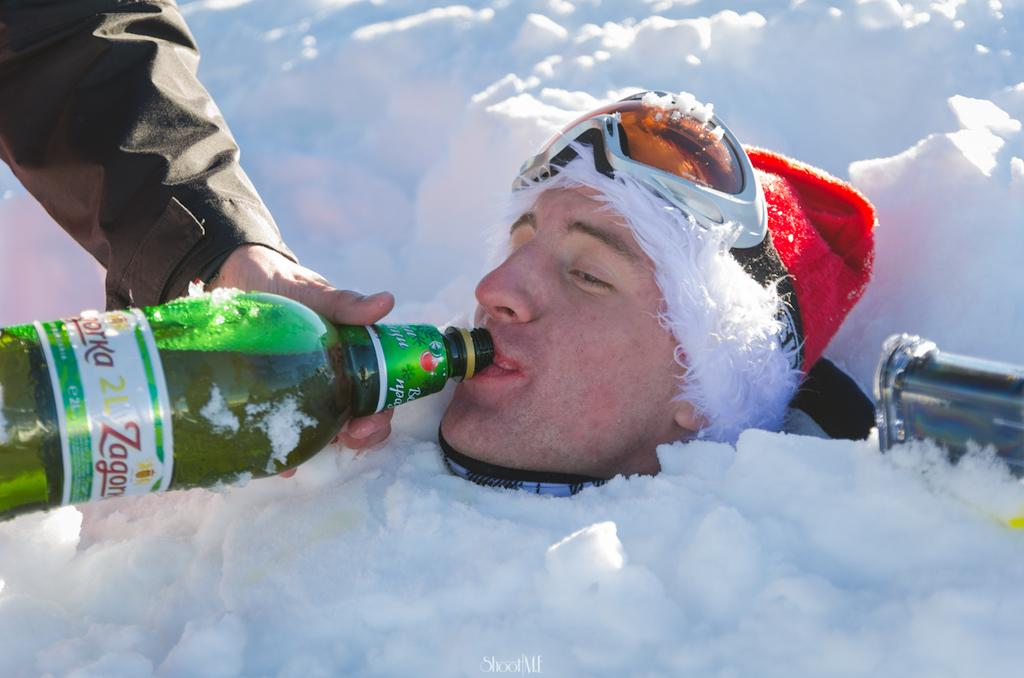What is the main subject of the image? There is a person in the image. What is the person's body doing in the image? The person's body is dipped in snow. What part of the person's body is visible in the image? Only the person's face is visible in the image. What is the person doing in the image? The person is drinking. What type of marble can be seen near the seashore in the image? There is no marble or seashore present in the image; it features a person with their body dipped in snow and only their face visible. 